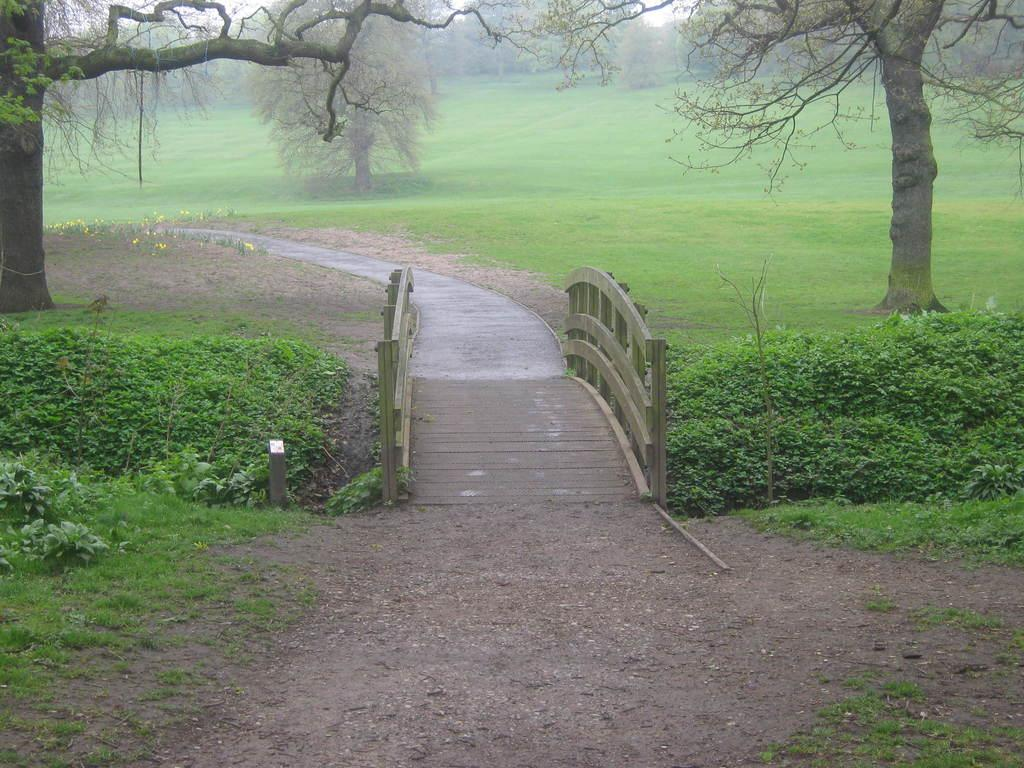What type of vegetation can be seen in the image? There are many trees in the image. What else can be seen in the image besides trees? There is grass visible in the image. Is there any man-made structure or feature in the image? Yes, there is a road beside the trees and grass. What type of rose can be seen growing on the trees in the image? There are no roses present in the image; it features trees and grass. How does the fuel consumption of the trees affect the environment in the image? There is no mention of fuel consumption in the image, as it focuses on trees, grass, and a road. 